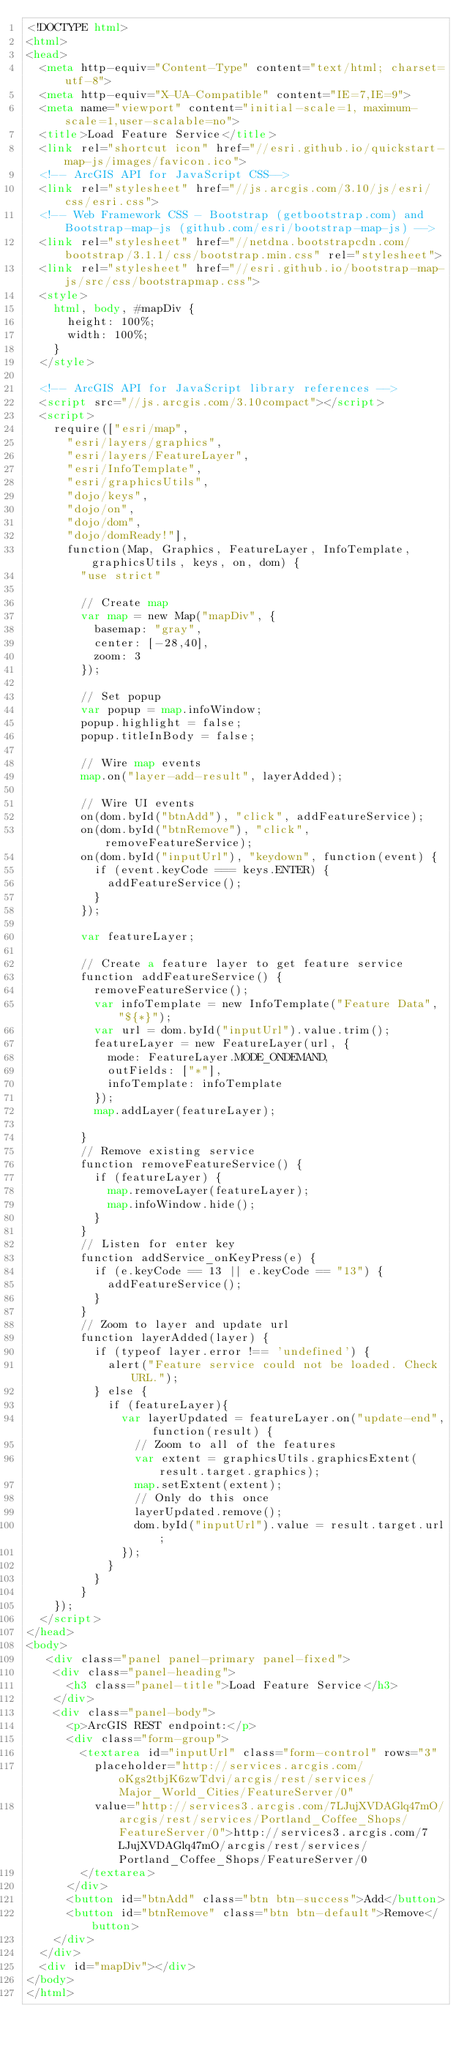<code> <loc_0><loc_0><loc_500><loc_500><_HTML_><!DOCTYPE html> 
<html>  
<head> 
  <meta http-equiv="Content-Type" content="text/html; charset=utf-8">
  <meta http-equiv="X-UA-Compatible" content="IE=7,IE=9">
  <meta name="viewport" content="initial-scale=1, maximum-scale=1,user-scalable=no">
  <title>Load Feature Service</title>  
  <link rel="shortcut icon" href="//esri.github.io/quickstart-map-js/images/favicon.ico">
  <!-- ArcGIS API for JavaScript CSS-->
  <link rel="stylesheet" href="//js.arcgis.com/3.10/js/esri/css/esri.css">
  <!-- Web Framework CSS - Bootstrap (getbootstrap.com) and Bootstrap-map-js (github.com/esri/bootstrap-map-js) -->
  <link rel="stylesheet" href="//netdna.bootstrapcdn.com/bootstrap/3.1.1/css/bootstrap.min.css" rel="stylesheet">
  <link rel="stylesheet" href="//esri.github.io/bootstrap-map-js/src/css/bootstrapmap.css">
  <style>
    html, body, #mapDiv {
      height: 100%;
      width: 100%;
    }
  </style>

  <!-- ArcGIS API for JavaScript library references -->
  <script src="//js.arcgis.com/3.10compact"></script>
  <script>
    require(["esri/map",
      "esri/layers/graphics", 
      "esri/layers/FeatureLayer", 
      "esri/InfoTemplate", 
      "esri/graphicsUtils",
      "dojo/keys",
      "dojo/on", 
      "dojo/dom", 
      "dojo/domReady!"], 
      function(Map, Graphics, FeatureLayer, InfoTemplate, graphicsUtils, keys, on, dom) {
        "use strict"
        
        // Create map
        var map = new Map("mapDiv", { 
          basemap: "gray",
          center: [-28,40],
          zoom: 3
        }); 

        // Set popup
        var popup = map.infoWindow;
        popup.highlight = false;
        popup.titleInBody = false;
        
        // Wire map events
        map.on("layer-add-result", layerAdded);

        // Wire UI events
        on(dom.byId("btnAdd"), "click", addFeatureService);        
        on(dom.byId("btnRemove"), "click", removeFeatureService);      
        on(dom.byId("inputUrl"), "keydown", function(event) {
          if (event.keyCode === keys.ENTER) {
            addFeatureService();
          }
        });

        var featureLayer;

        // Create a feature layer to get feature service
        function addFeatureService() {
          removeFeatureService();
          var infoTemplate = new InfoTemplate("Feature Data", "${*}");
          var url = dom.byId("inputUrl").value.trim();    
          featureLayer = new FeatureLayer(url, {
            mode: FeatureLayer.MODE_ONDEMAND,
            outFields: ["*"],
            infoTemplate: infoTemplate
          });
          map.addLayer(featureLayer);
          
        }
        // Remove existing service
        function removeFeatureService() {
          if (featureLayer) {
            map.removeLayer(featureLayer);
            map.infoWindow.hide();
          }
        }
        // Listen for enter key
        function addService_onKeyPress(e) {
          if (e.keyCode == 13 || e.keyCode == "13") {
            addFeatureService();
          }
        }
        // Zoom to layer and update url
        function layerAdded(layer) {
          if (typeof layer.error !== 'undefined') {
            alert("Feature service could not be loaded. Check URL.");
          } else {
            if (featureLayer){
              var layerUpdated = featureLayer.on("update-end", function(result) {
                // Zoom to all of the features   
                var extent = graphicsUtils.graphicsExtent(result.target.graphics);   
                map.setExtent(extent);
                // Only do this once
                layerUpdated.remove();
                dom.byId("inputUrl").value = result.target.url;    
              });
            }
          }
        }
    });
  </script>
</head>
<body>
   <div class="panel panel-primary panel-fixed">
    <div class="panel-heading">
      <h3 class="panel-title">Load Feature Service</h3>
    </div>
    <div class="panel-body">
      <p>ArcGIS REST endpoint:</p>
      <div class="form-group">
        <textarea id="inputUrl" class="form-control" rows="3" 
          placeholder="http://services.arcgis.com/oKgs2tbjK6zwTdvi/arcgis/rest/services/Major_World_Cities/FeatureServer/0"  
          value="http://services3.arcgis.com/7LJujXVDAGlq47mO/arcgis/rest/services/Portland_Coffee_Shops/FeatureServer/0">http://services3.arcgis.com/7LJujXVDAGlq47mO/arcgis/rest/services/Portland_Coffee_Shops/FeatureServer/0
        </textarea>
      </div>
      <button id="btnAdd" class="btn btn-success">Add</button>
      <button id="btnRemove" class="btn btn-default">Remove</button>
    </div>
  </div>
  <div id="mapDiv"></div>
</body>
</html>
</code> 